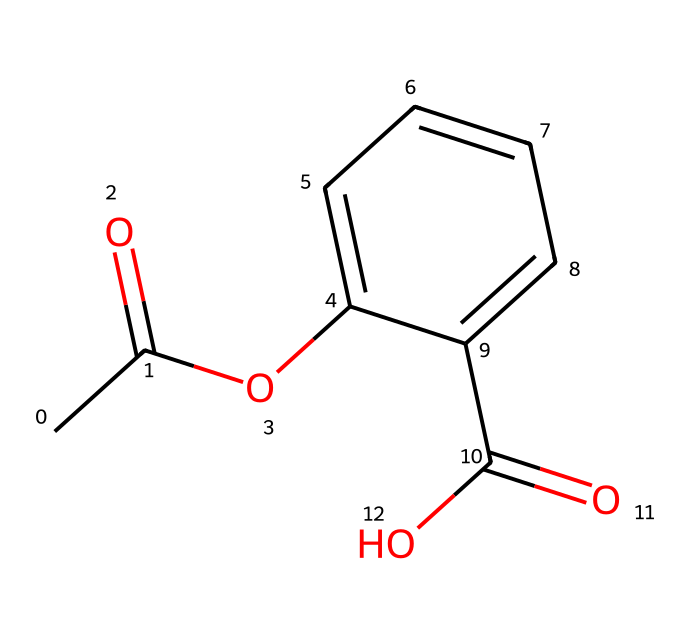What is the common name of this chemical? The provided SMILES structure corresponds to acetylsalicylic acid, which is commonly known as aspirin.
Answer: aspirin How many carbon atoms are in this molecule? Analyzing the SMILES notation, there are 9 carbon atoms found in the structure, indicated by the 'C' characters before and within the structure.
Answer: 9 How many functional groups are present in this molecule? The structure contains two functional groups: an ester group (indicated by the -O- connecting two parts of the molecule) and a carboxylic acid group (indicated by the -C(=O)O). Therefore, there are two functional groups.
Answer: 2 What type of acid is acetylsalicylic acid classified as? Acetylsalicylic acid is classified as a salicylic acid derivative, which is a type of carboxylic acid due to its carboxylic functional group present in the structure.
Answer: carboxylic acid What is the contribution of the acetyl group to the properties of the acid? The acetyl group contributes to the lipophilicity of acetylsalicylic acid, enhancing its ability to penetrate cell membranes. This affects the absorption and effects of the drug within the body, especially in relation to impulsivity and pain management.
Answer: lipophilicity 